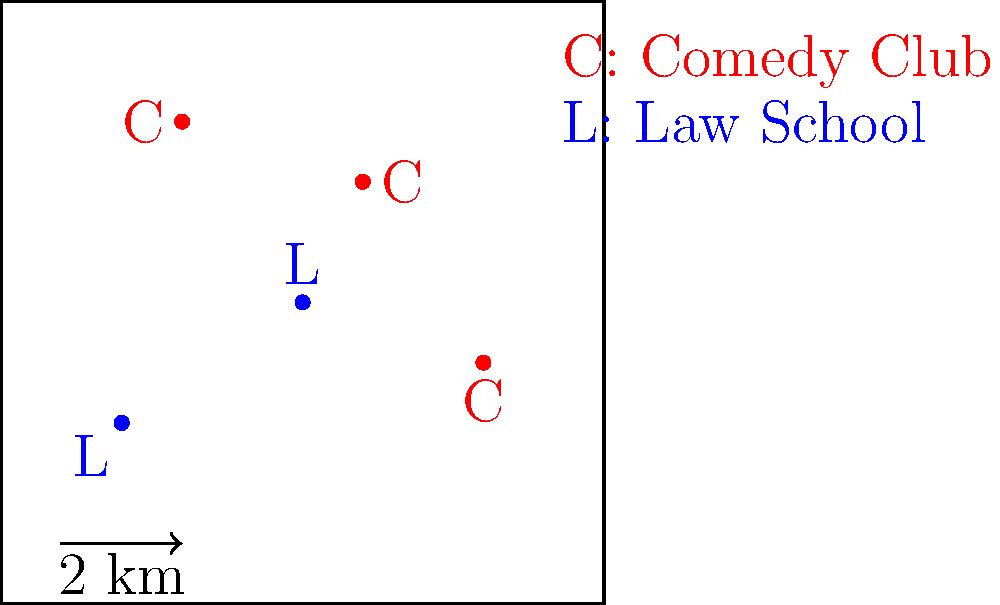In the city map above, comedy clubs (C) and law schools (L) are plotted. Calculate the average distance between each comedy club and its nearest law school. Round your answer to the nearest tenth of a kilometer. To solve this problem, we'll follow these steps:

1. Identify the nearest law school for each comedy club.
2. Calculate the distance between each comedy club and its nearest law school.
3. Find the average of these distances.

Step 1: Identify nearest law schools
- For C(1,2) and C(-2,3), the nearest law school is L(0,0)
- For C(3,-1), the nearest law school is L(0,0)

Step 2: Calculate distances
Using the distance formula: $d = \sqrt{(x_2-x_1)^2 + (y_2-y_1)^2}$

For C(1,2) to L(0,0):
$d_1 = \sqrt{(0-1)^2 + (0-2)^2} = \sqrt{1 + 4} = \sqrt{5} \approx 2.24$ km

For C(-2,3) to L(0,0):
$d_2 = \sqrt{(0-(-2))^2 + (0-3)^2} = \sqrt{4 + 9} = \sqrt{13} \approx 3.61$ km

For C(3,-1) to L(0,0):
$d_3 = \sqrt{(0-3)^2 + (0-(-1))^2} = \sqrt{9 + 1} = \sqrt{10} \approx 3.16$ km

Step 3: Calculate average distance
Average distance = $\frac{d_1 + d_2 + d_3}{3} = \frac{2.24 + 3.61 + 3.16}{3} \approx 3.0$ km

Rounding to the nearest tenth, we get 3.0 km.
Answer: 3.0 km 